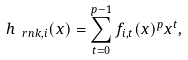<formula> <loc_0><loc_0><loc_500><loc_500>h _ { \ r n k , i } ( x ) = \sum _ { t = 0 } ^ { p - 1 } f _ { i , t } ( x ) ^ { p } x ^ { t } ,</formula> 